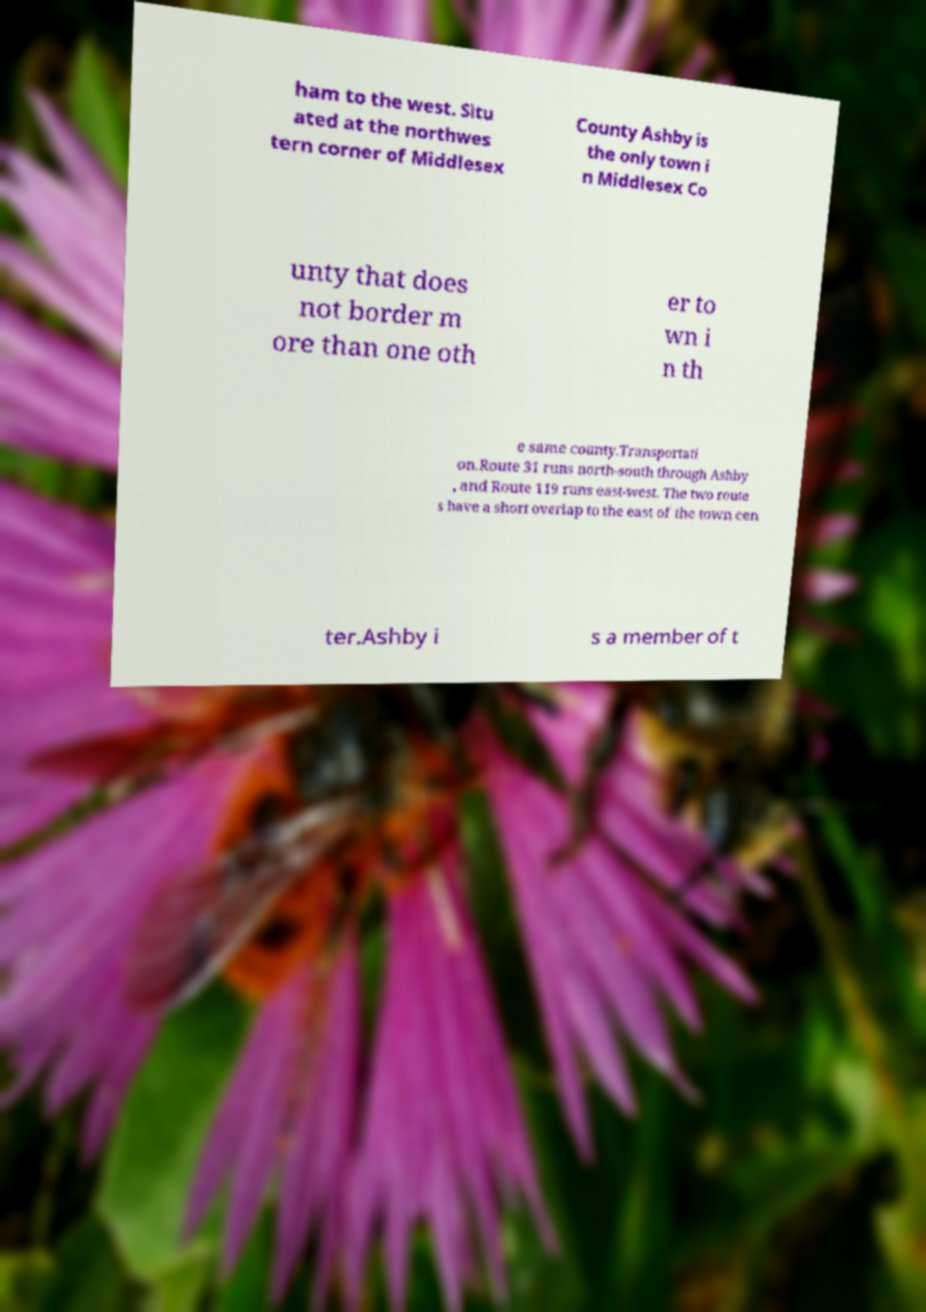What messages or text are displayed in this image? I need them in a readable, typed format. ham to the west. Situ ated at the northwes tern corner of Middlesex County Ashby is the only town i n Middlesex Co unty that does not border m ore than one oth er to wn i n th e same county.Transportati on.Route 31 runs north-south through Ashby , and Route 119 runs east-west. The two route s have a short overlap to the east of the town cen ter.Ashby i s a member of t 